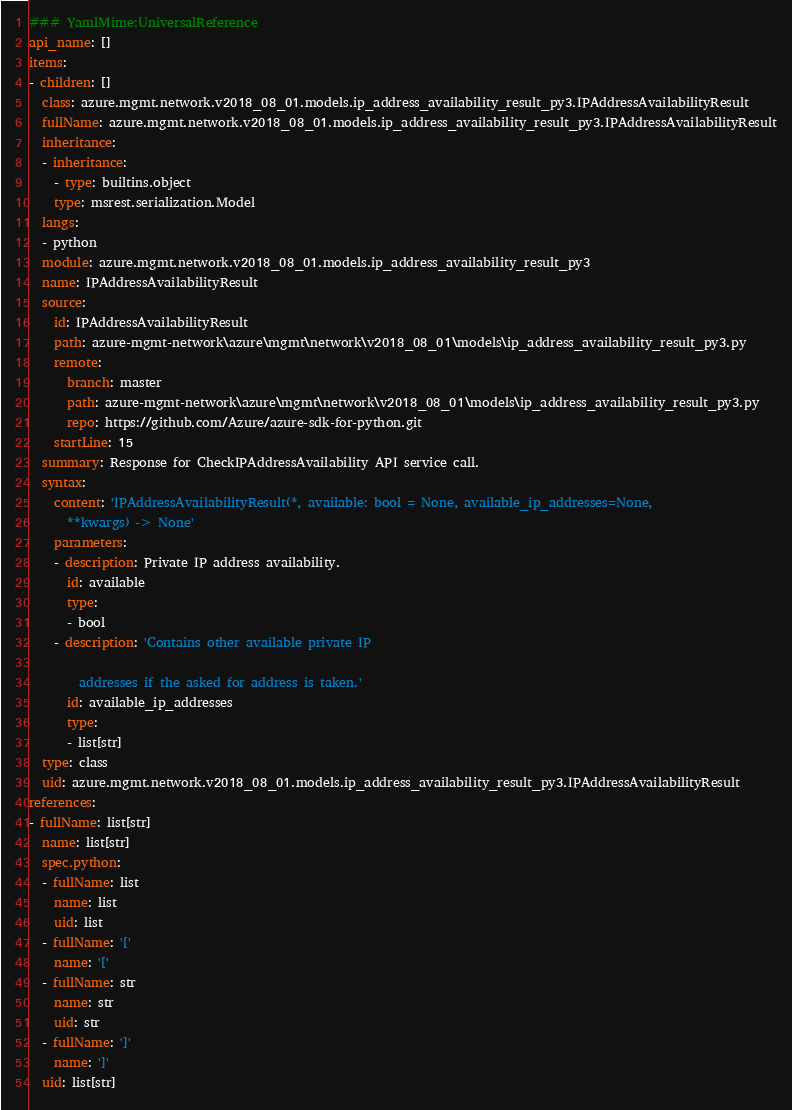Convert code to text. <code><loc_0><loc_0><loc_500><loc_500><_YAML_>### YamlMime:UniversalReference
api_name: []
items:
- children: []
  class: azure.mgmt.network.v2018_08_01.models.ip_address_availability_result_py3.IPAddressAvailabilityResult
  fullName: azure.mgmt.network.v2018_08_01.models.ip_address_availability_result_py3.IPAddressAvailabilityResult
  inheritance:
  - inheritance:
    - type: builtins.object
    type: msrest.serialization.Model
  langs:
  - python
  module: azure.mgmt.network.v2018_08_01.models.ip_address_availability_result_py3
  name: IPAddressAvailabilityResult
  source:
    id: IPAddressAvailabilityResult
    path: azure-mgmt-network\azure\mgmt\network\v2018_08_01\models\ip_address_availability_result_py3.py
    remote:
      branch: master
      path: azure-mgmt-network\azure\mgmt\network\v2018_08_01\models\ip_address_availability_result_py3.py
      repo: https://github.com/Azure/azure-sdk-for-python.git
    startLine: 15
  summary: Response for CheckIPAddressAvailability API service call.
  syntax:
    content: 'IPAddressAvailabilityResult(*, available: bool = None, available_ip_addresses=None,
      **kwargs) -> None'
    parameters:
    - description: Private IP address availability.
      id: available
      type:
      - bool
    - description: 'Contains other available private IP

        addresses if the asked for address is taken.'
      id: available_ip_addresses
      type:
      - list[str]
  type: class
  uid: azure.mgmt.network.v2018_08_01.models.ip_address_availability_result_py3.IPAddressAvailabilityResult
references:
- fullName: list[str]
  name: list[str]
  spec.python:
  - fullName: list
    name: list
    uid: list
  - fullName: '['
    name: '['
  - fullName: str
    name: str
    uid: str
  - fullName: ']'
    name: ']'
  uid: list[str]
</code> 